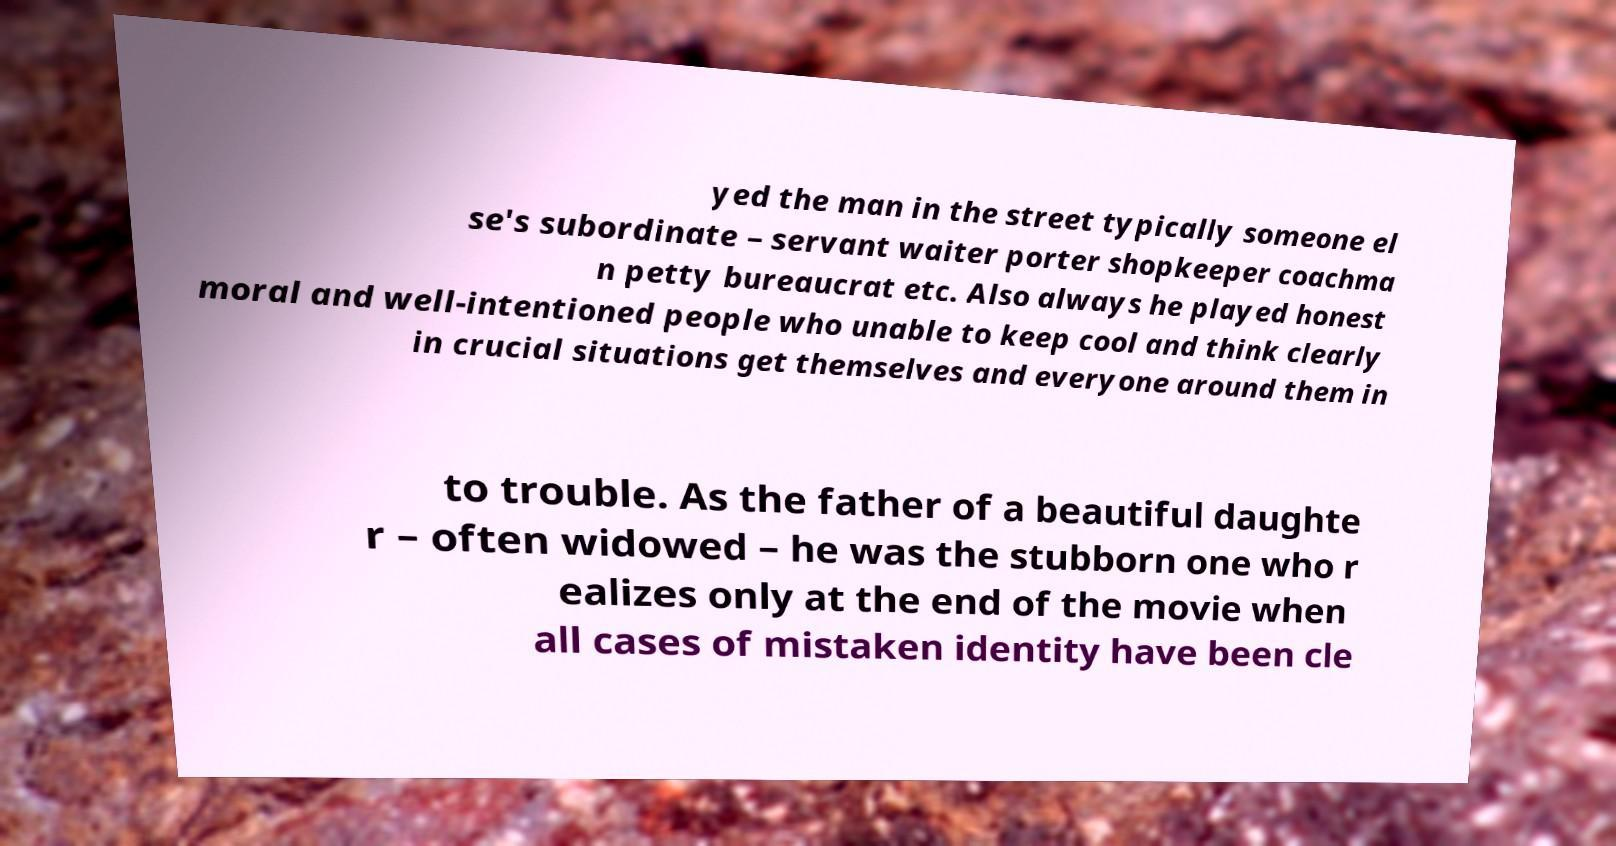Please read and relay the text visible in this image. What does it say? yed the man in the street typically someone el se's subordinate – servant waiter porter shopkeeper coachma n petty bureaucrat etc. Also always he played honest moral and well-intentioned people who unable to keep cool and think clearly in crucial situations get themselves and everyone around them in to trouble. As the father of a beautiful daughte r – often widowed – he was the stubborn one who r ealizes only at the end of the movie when all cases of mistaken identity have been cle 